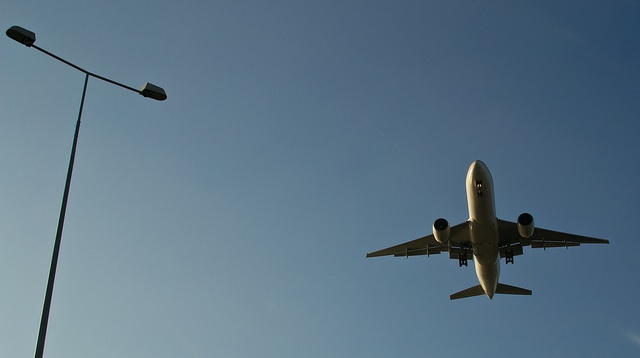Describe the objects in this image and their specific colors. I can see a airplane in gray, black, and blue tones in this image. 